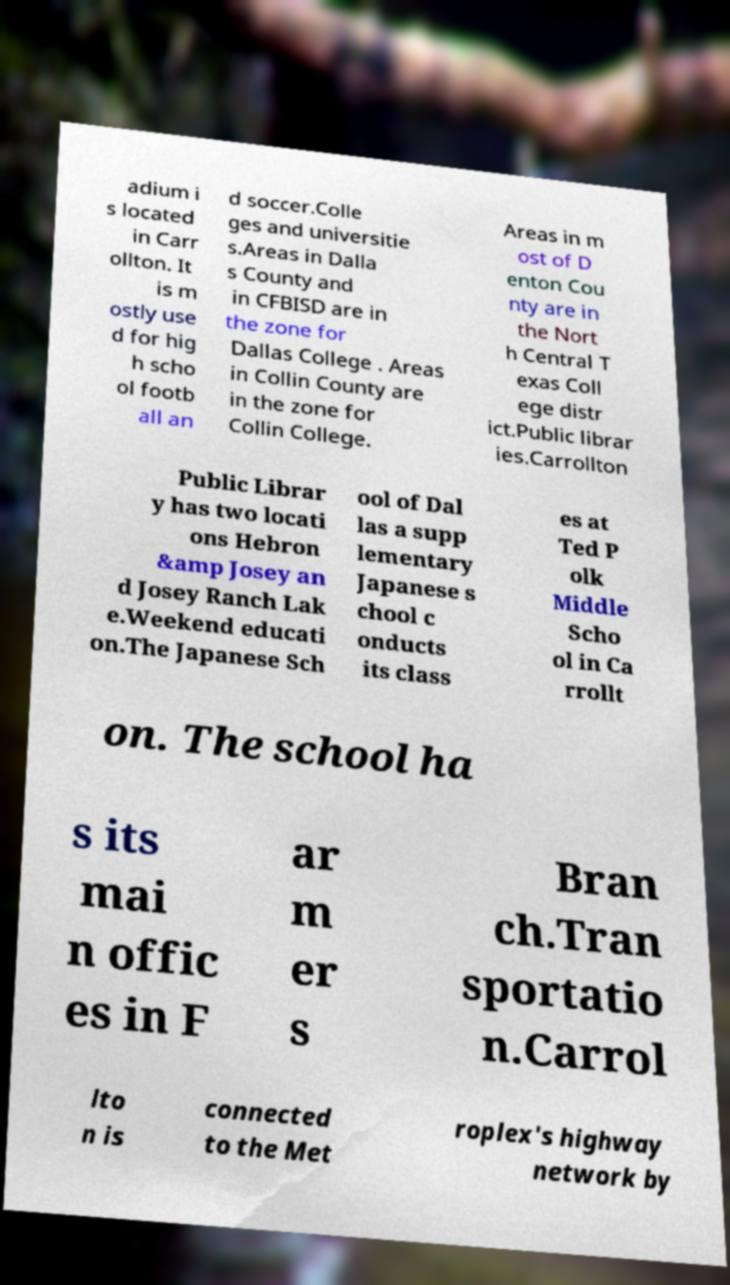I need the written content from this picture converted into text. Can you do that? adium i s located in Carr ollton. It is m ostly use d for hig h scho ol footb all an d soccer.Colle ges and universitie s.Areas in Dalla s County and in CFBISD are in the zone for Dallas College . Areas in Collin County are in the zone for Collin College. Areas in m ost of D enton Cou nty are in the Nort h Central T exas Coll ege distr ict.Public librar ies.Carrollton Public Librar y has two locati ons Hebron &amp Josey an d Josey Ranch Lak e.Weekend educati on.The Japanese Sch ool of Dal las a supp lementary Japanese s chool c onducts its class es at Ted P olk Middle Scho ol in Ca rrollt on. The school ha s its mai n offic es in F ar m er s Bran ch.Tran sportatio n.Carrol lto n is connected to the Met roplex's highway network by 